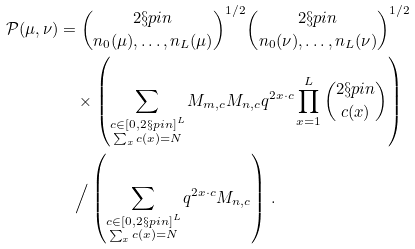Convert formula to latex. <formula><loc_0><loc_0><loc_500><loc_500>\mathcal { P } ( \mu , \nu ) & = \binom { 2 \S p i n } { n _ { 0 } ( \mu ) , \dots , n _ { L } ( \mu ) } ^ { 1 / 2 } \binom { 2 \S p i n } { n _ { 0 } ( \nu ) , \dots , n _ { L } ( \nu ) } ^ { 1 / 2 } \\ & \quad \times \left ( \sum _ { \substack { c \in [ 0 , 2 \S p i n ] ^ { L } \\ \sum _ { x } c ( x ) = N } } M _ { m , c } M _ { n , c } q ^ { 2 x \cdot c } \prod _ { x = 1 } ^ { L } \binom { 2 \S p i n } { c ( x ) } \right ) \\ & \quad \Big / \left ( \sum _ { \substack { c \in [ 0 , 2 \S p i n ] ^ { L } \\ \sum _ { x } c ( x ) = N } } q ^ { 2 x \cdot c } M _ { n , c } \right ) \, .</formula> 